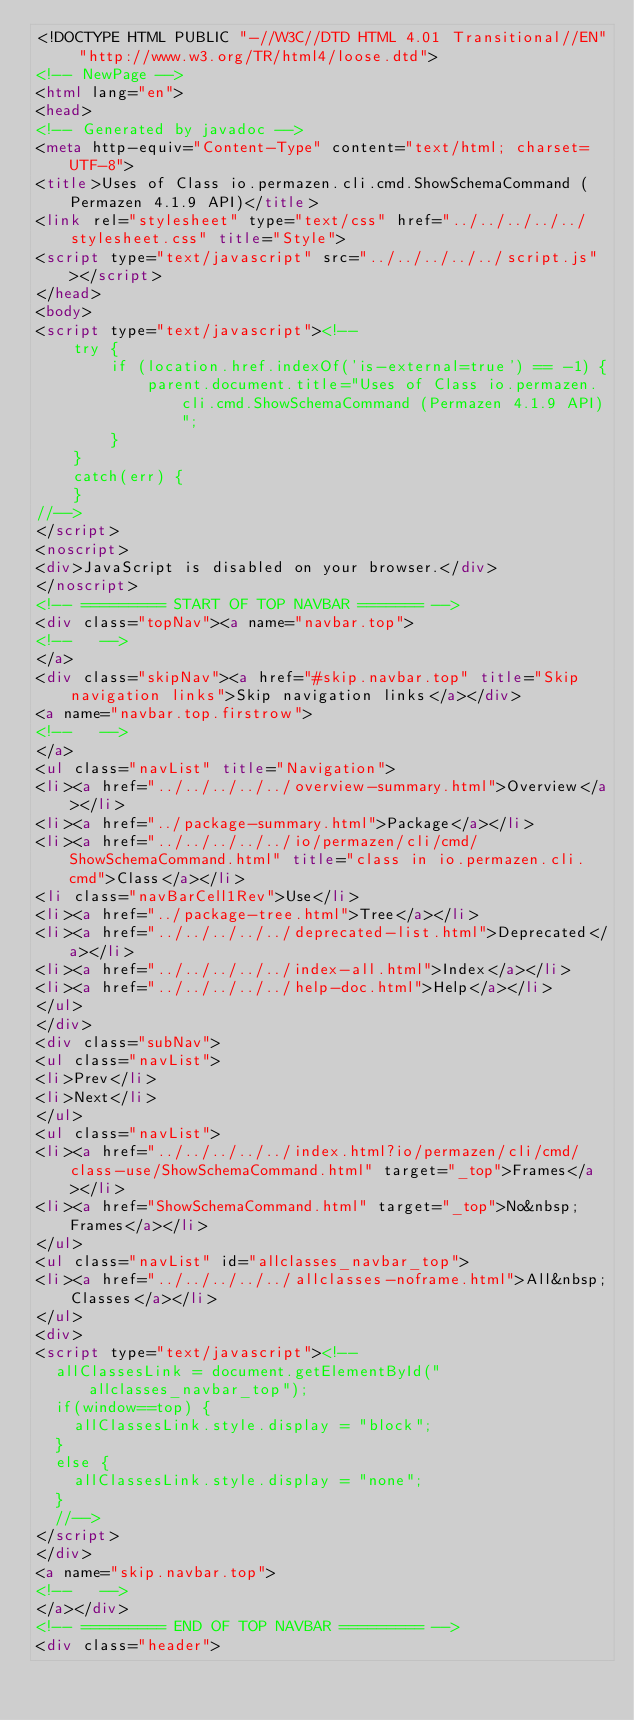Convert code to text. <code><loc_0><loc_0><loc_500><loc_500><_HTML_><!DOCTYPE HTML PUBLIC "-//W3C//DTD HTML 4.01 Transitional//EN" "http://www.w3.org/TR/html4/loose.dtd">
<!-- NewPage -->
<html lang="en">
<head>
<!-- Generated by javadoc -->
<meta http-equiv="Content-Type" content="text/html; charset=UTF-8">
<title>Uses of Class io.permazen.cli.cmd.ShowSchemaCommand (Permazen 4.1.9 API)</title>
<link rel="stylesheet" type="text/css" href="../../../../../stylesheet.css" title="Style">
<script type="text/javascript" src="../../../../../script.js"></script>
</head>
<body>
<script type="text/javascript"><!--
    try {
        if (location.href.indexOf('is-external=true') == -1) {
            parent.document.title="Uses of Class io.permazen.cli.cmd.ShowSchemaCommand (Permazen 4.1.9 API)";
        }
    }
    catch(err) {
    }
//-->
</script>
<noscript>
<div>JavaScript is disabled on your browser.</div>
</noscript>
<!-- ========= START OF TOP NAVBAR ======= -->
<div class="topNav"><a name="navbar.top">
<!--   -->
</a>
<div class="skipNav"><a href="#skip.navbar.top" title="Skip navigation links">Skip navigation links</a></div>
<a name="navbar.top.firstrow">
<!--   -->
</a>
<ul class="navList" title="Navigation">
<li><a href="../../../../../overview-summary.html">Overview</a></li>
<li><a href="../package-summary.html">Package</a></li>
<li><a href="../../../../../io/permazen/cli/cmd/ShowSchemaCommand.html" title="class in io.permazen.cli.cmd">Class</a></li>
<li class="navBarCell1Rev">Use</li>
<li><a href="../package-tree.html">Tree</a></li>
<li><a href="../../../../../deprecated-list.html">Deprecated</a></li>
<li><a href="../../../../../index-all.html">Index</a></li>
<li><a href="../../../../../help-doc.html">Help</a></li>
</ul>
</div>
<div class="subNav">
<ul class="navList">
<li>Prev</li>
<li>Next</li>
</ul>
<ul class="navList">
<li><a href="../../../../../index.html?io/permazen/cli/cmd/class-use/ShowSchemaCommand.html" target="_top">Frames</a></li>
<li><a href="ShowSchemaCommand.html" target="_top">No&nbsp;Frames</a></li>
</ul>
<ul class="navList" id="allclasses_navbar_top">
<li><a href="../../../../../allclasses-noframe.html">All&nbsp;Classes</a></li>
</ul>
<div>
<script type="text/javascript"><!--
  allClassesLink = document.getElementById("allclasses_navbar_top");
  if(window==top) {
    allClassesLink.style.display = "block";
  }
  else {
    allClassesLink.style.display = "none";
  }
  //-->
</script>
</div>
<a name="skip.navbar.top">
<!--   -->
</a></div>
<!-- ========= END OF TOP NAVBAR ========= -->
<div class="header"></code> 